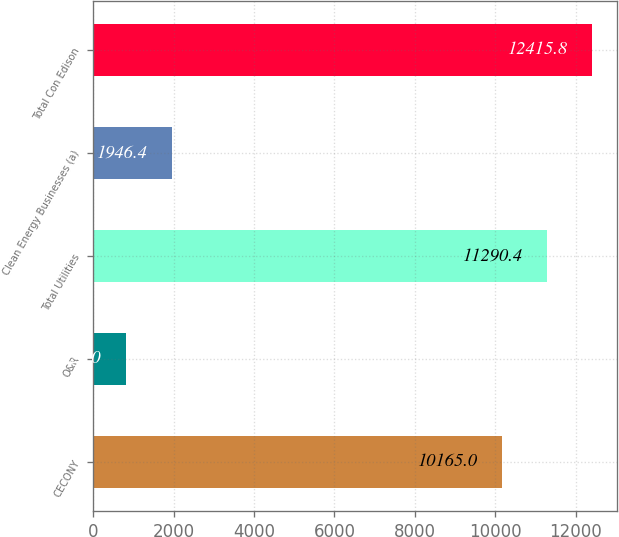<chart> <loc_0><loc_0><loc_500><loc_500><bar_chart><fcel>CECONY<fcel>O&R<fcel>Total Utilities<fcel>Clean Energy Businesses (a)<fcel>Total Con Edison<nl><fcel>10165<fcel>821<fcel>11290.4<fcel>1946.4<fcel>12415.8<nl></chart> 